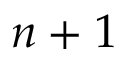Convert formula to latex. <formula><loc_0><loc_0><loc_500><loc_500>n + 1</formula> 